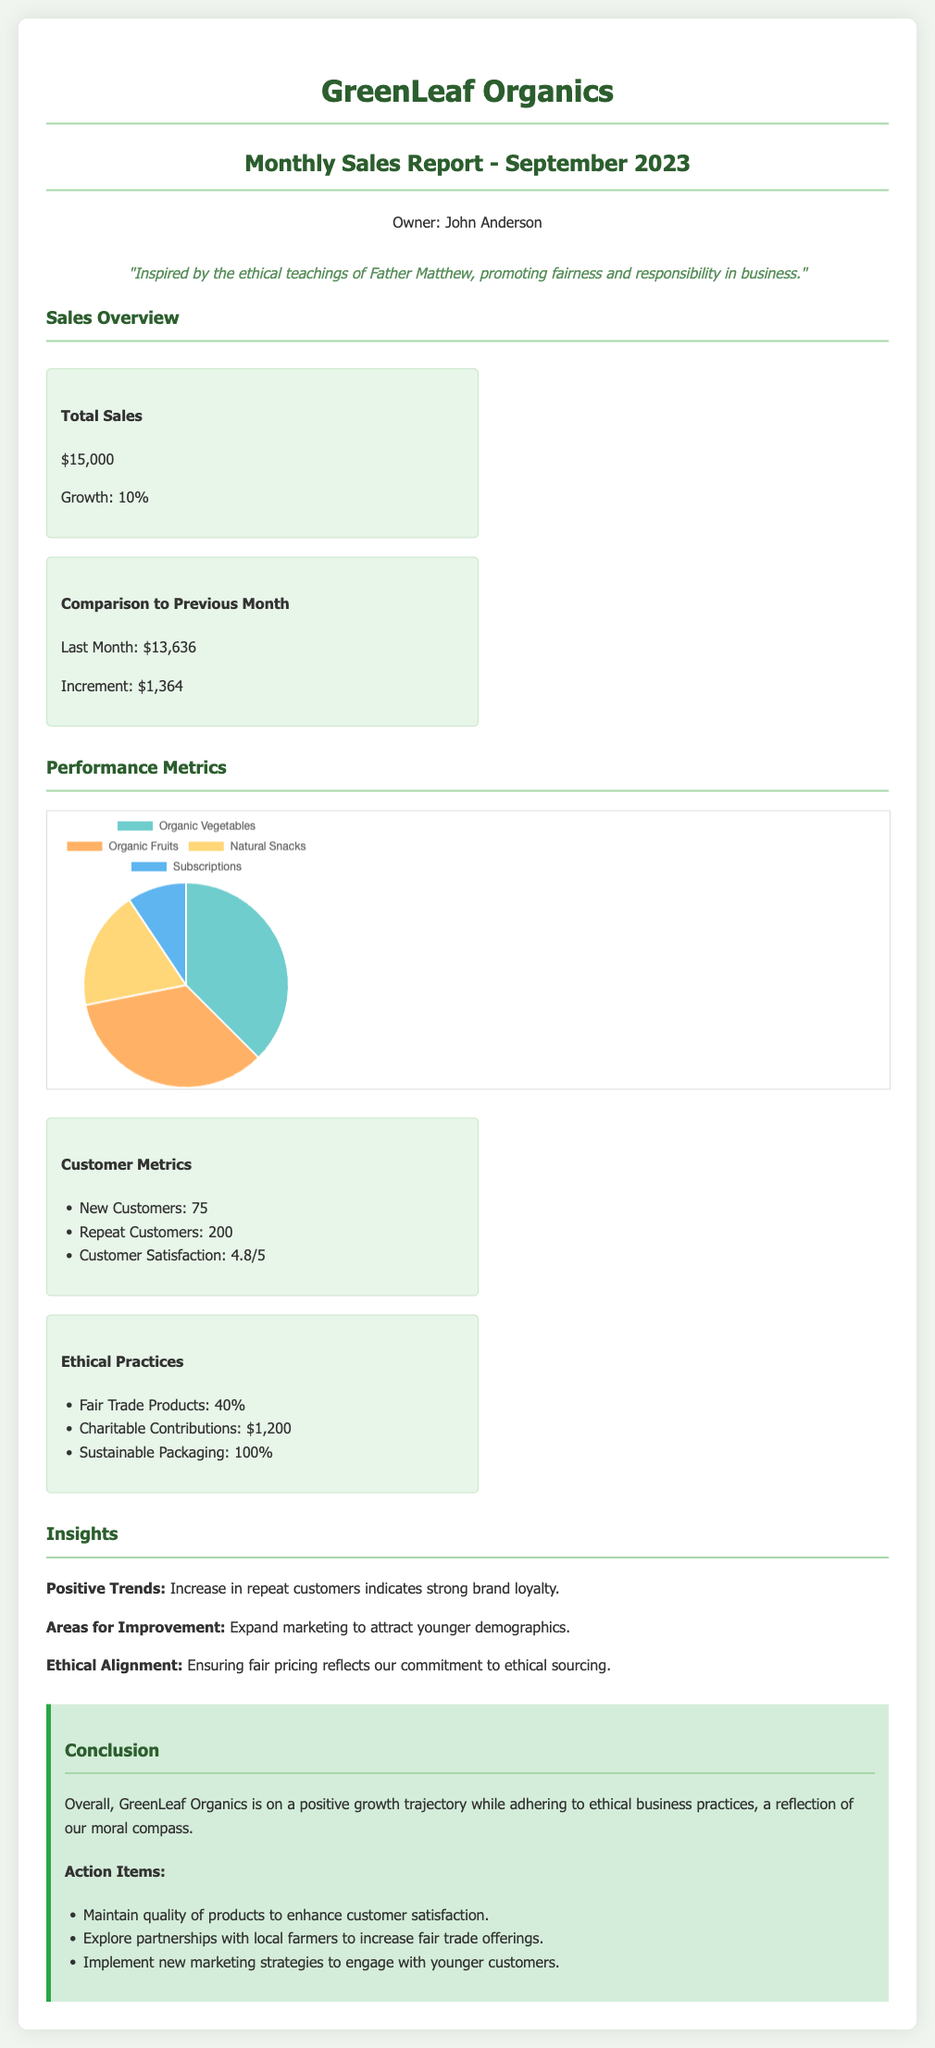What is the total sales for September 2023? The total sales amount for September 2023 is directly stated in the document.
Answer: $15,000 What was the sales growth percentage? The document specifies the growth percentage as part of the sales overview.
Answer: 10% How many new customers were acquired? This metric is provided in the customer metrics section of the document.
Answer: 75 What percentage of products are Fair Trade? This information is included in the ethical practices section of the report.
Answer: 40% What is the customer satisfaction rating? The customer satisfaction score is detailed in the customer metrics area of the document.
Answer: 4.8/5 What was the charitable contributions amount? The specific figure for charitable contributions is found under ethical practices.
Answer: $1,200 What is one area for improvement mentioned? The insights section outlines areas for improvement regarding marketing strategies.
Answer: Attract younger demographics What type of chart is used to represent sales by category? The document describes a particular chart type used for sales representation.
Answer: Pie chart What is the conclusion about the company's growth? The conclusion summarizes the overall growth assessment in ethical business practices.
Answer: Positive growth trajectory 